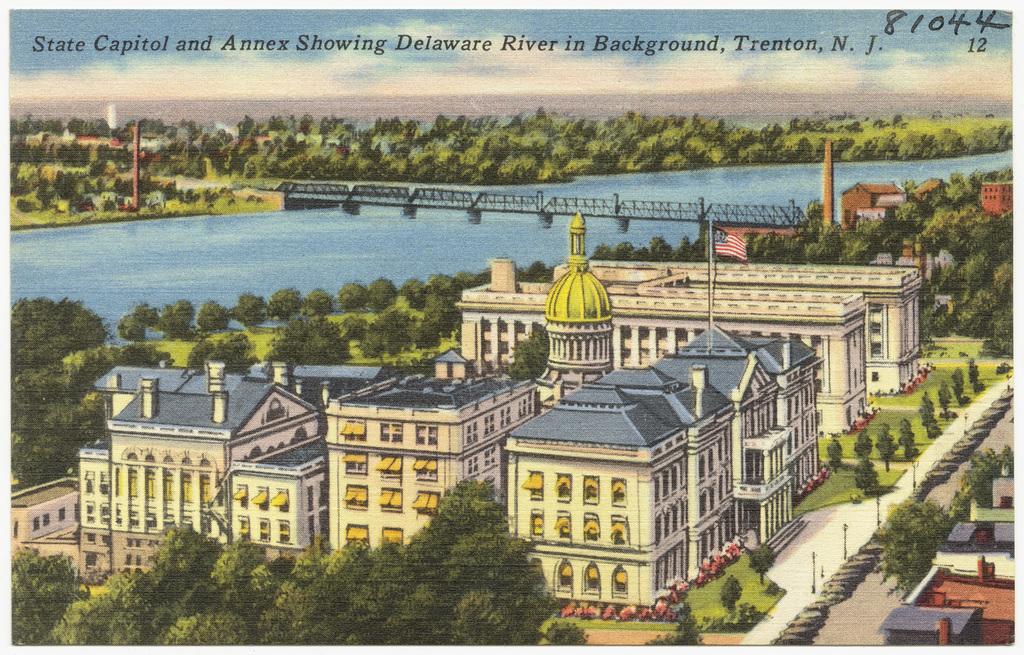What river is shown?
Make the answer very short. Delaware river. 